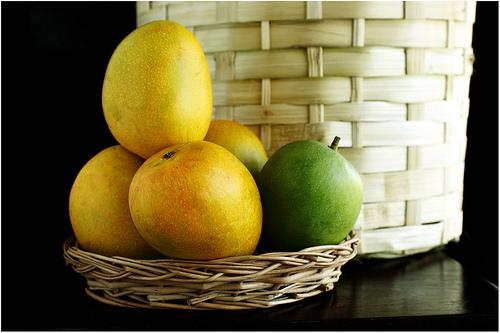Question: what is kept inside the basket?
Choices:
A. Potatoes.
B. Bread.
C. Fruit.
D. Fish.
Answer with the letter. Answer: C Question: how many oranges are in the picture?
Choices:
A. 4.
B. 5.
C. 6.
D. 12.
Answer with the letter. Answer: A Question: how many baskets are there?
Choices:
A. 3.
B. 4.
C. 2.
D. 5.
Answer with the letter. Answer: C Question: how many apples are in the photo?
Choices:
A. Two.
B. Three.
C. Four.
D. One.
Answer with the letter. Answer: D Question: how many green things are there?
Choices:
A. One.
B. None.
C. Two.
D. Three.
Answer with the letter. Answer: A 